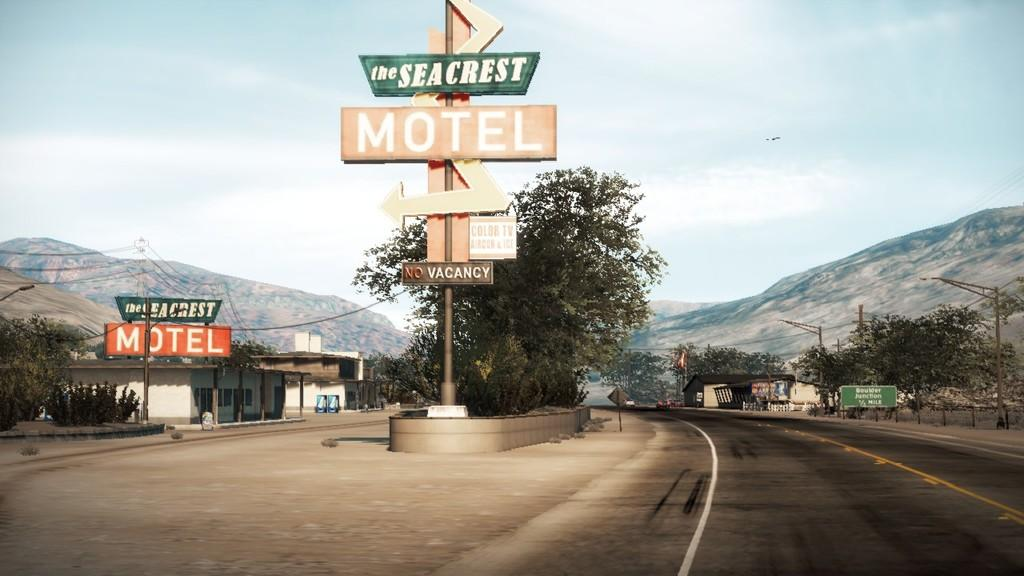<image>
Summarize the visual content of the image. A signpost reads "The Seacrest Motel" in full 